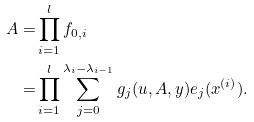Convert formula to latex. <formula><loc_0><loc_0><loc_500><loc_500>A = & \prod _ { i = 1 } ^ { l } f _ { 0 , i } \\ = & \prod _ { i = 1 } ^ { l } \sum _ { j = 0 } ^ { \lambda _ { i } - \lambda _ { i - 1 } } g _ { j } ( u , A , y ) e _ { j } ( x ^ { ( i ) } ) .</formula> 